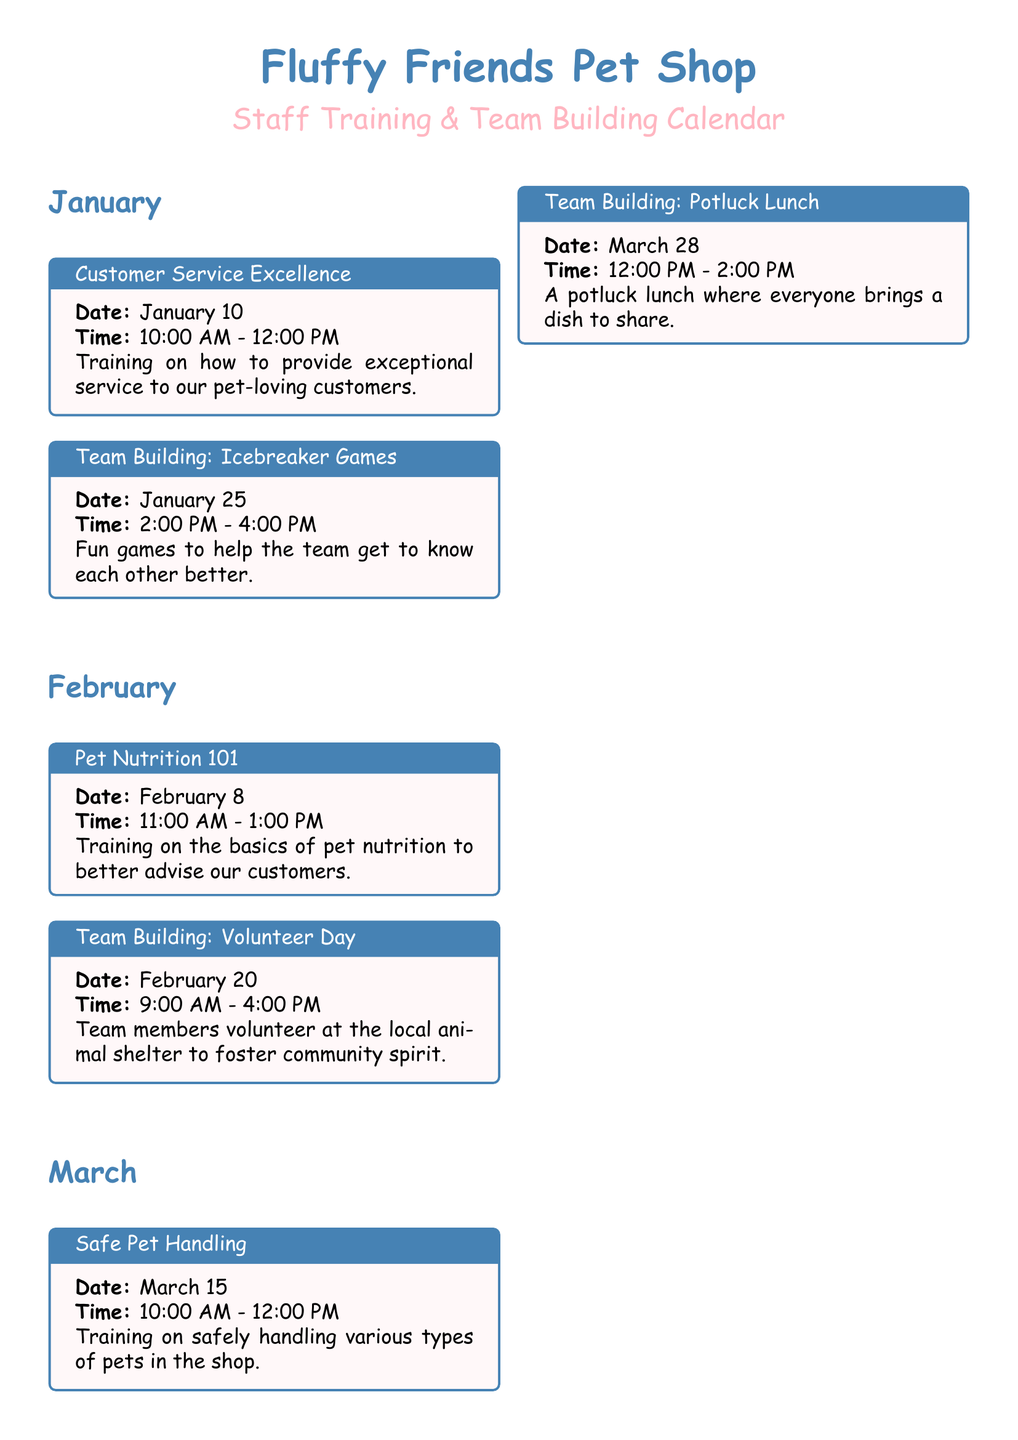What date is the Customer Service Excellence training scheduled for? The document states that the Customer Service Excellence training is scheduled for January 10.
Answer: January 10 What time does the Team Building: Icebreaker Games session start? The document indicates that the Team Building: Icebreaker Games session starts at 2:00 PM.
Answer: 2:00 PM What is the title of the training on February 8? According to the document, the training on February 8 is titled "Pet Nutrition 101."
Answer: Pet Nutrition 101 How many team building activities are scheduled in March? The document lists two team building activities for March: Potluck Lunch and Safe Pet Handling.
Answer: 2 What is the time span for the Volunteer Day activity? The document says that Volunteer Day lasts from 9:00 AM to 4:00 PM.
Answer: 9:00 AM - 4:00 PM Which month features the Effective Communication Skills training? The document specifies that the Effective Communication Skills training is in April.
Answer: April What type of event is scheduled for May 22? The document indicates that a Team Building: Movie Night is scheduled for May 22.
Answer: Movie Night How many training sessions are listed before April? The document lists three training sessions before April: Customer Service Excellence, Pet Nutrition 101, and Safe Pet Handling.
Answer: 3 Which event takes place at 1:00 PM on April 30? The document states that the Team Building: Outdoor Picnic takes place at 1:00 PM on April 30.
Answer: Outdoor Picnic 